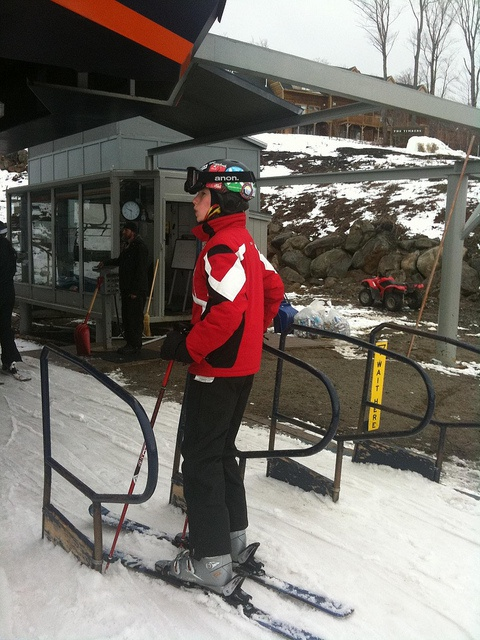Describe the objects in this image and their specific colors. I can see people in black, brown, and gray tones, skis in black, lightgray, darkgray, and gray tones, people in black, maroon, and gray tones, people in black, gray, darkgray, and white tones, and clock in black, gray, and purple tones in this image. 